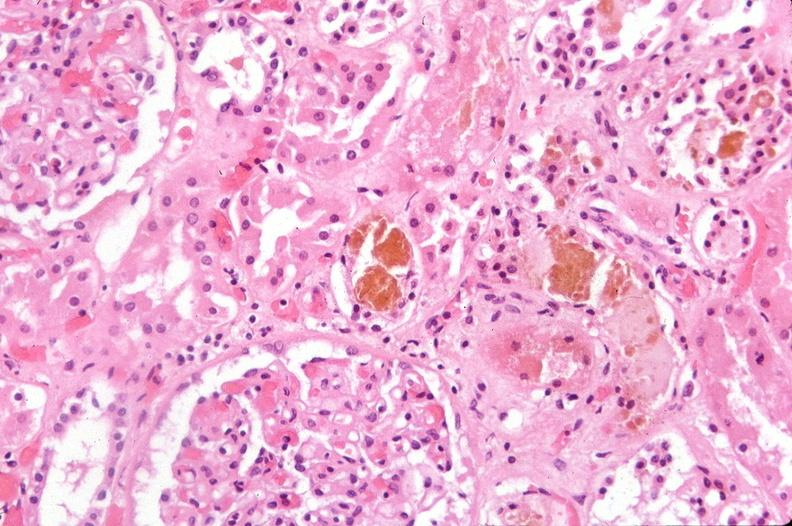where is this?
Answer the question using a single word or phrase. Urinary 